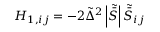Convert formula to latex. <formula><loc_0><loc_0><loc_500><loc_500>H _ { 1 , i j } = - 2 { \tilde { \Delta } ^ { 2 } } \left | { \tilde { \bar { S } } } \right | { \tilde { \bar { S } } _ { i j } }</formula> 